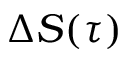Convert formula to latex. <formula><loc_0><loc_0><loc_500><loc_500>\Delta S ( \tau )</formula> 